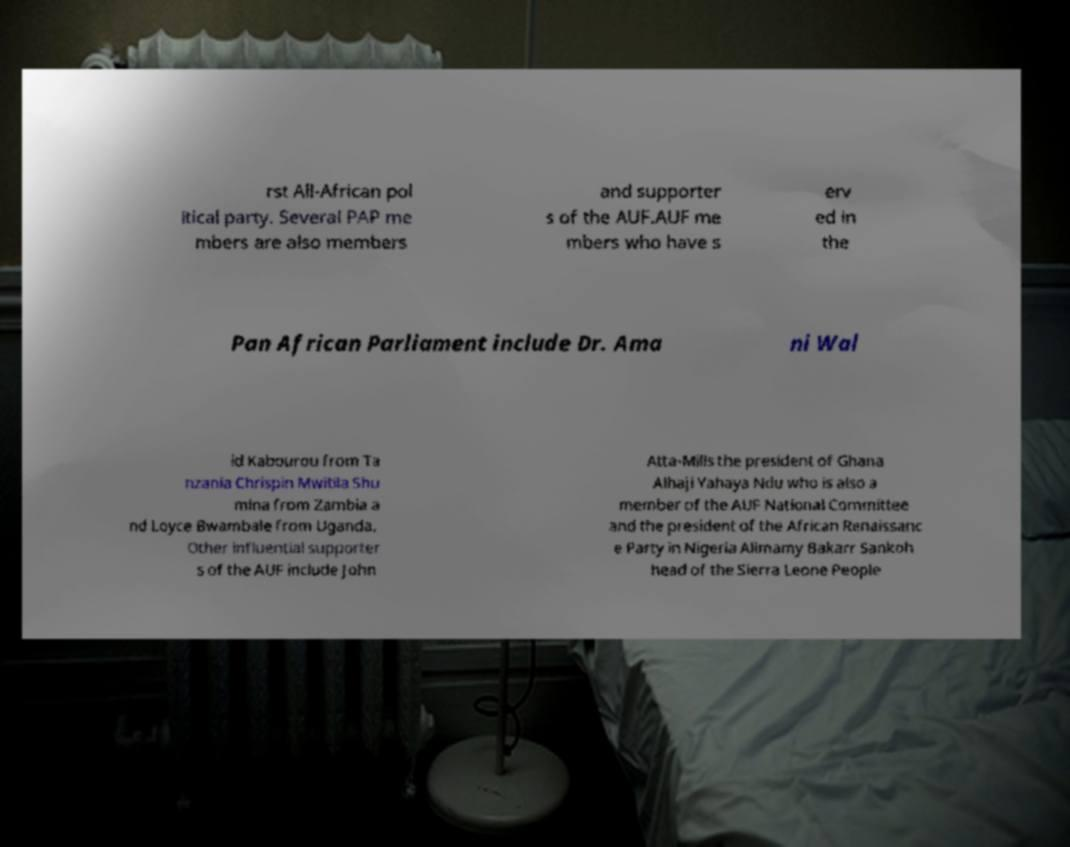I need the written content from this picture converted into text. Can you do that? rst All-African pol itical party. Several PAP me mbers are also members and supporter s of the AUF.AUF me mbers who have s erv ed in the Pan African Parliament include Dr. Ama ni Wal id Kabourou from Ta nzania Chrispin Mwitila Shu mina from Zambia a nd Loyce Bwambale from Uganda. Other influential supporter s of the AUF include John Atta-Mills the president of Ghana Alhaji Yahaya Ndu who is also a member of the AUF National Committee and the president of the African Renaissanc e Party in Nigeria Alimamy Bakarr Sankoh head of the Sierra Leone People 